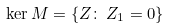<formula> <loc_0><loc_0><loc_500><loc_500>\ker M = \{ Z \colon \, Z _ { 1 } = 0 \}</formula> 